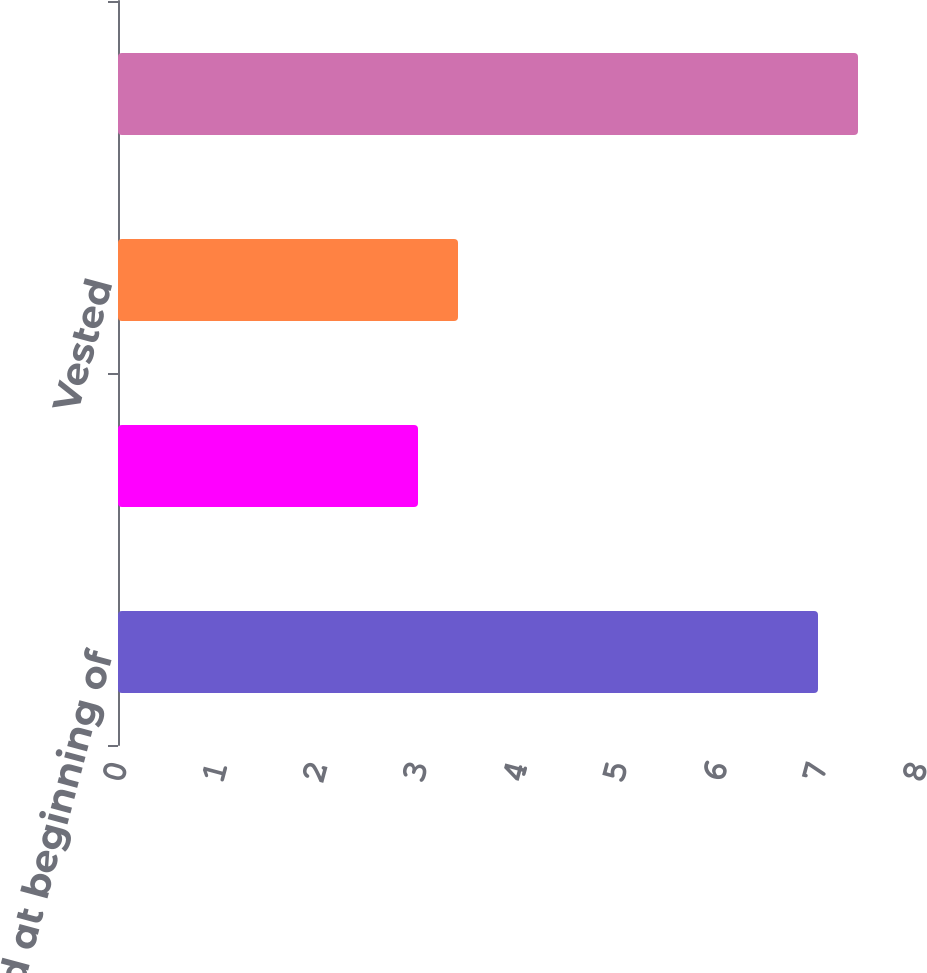Convert chart. <chart><loc_0><loc_0><loc_500><loc_500><bar_chart><fcel>Nonvested at beginning of<fcel>Granted<fcel>Vested<fcel>Nonvested at end of period<nl><fcel>7<fcel>3<fcel>3.4<fcel>7.4<nl></chart> 